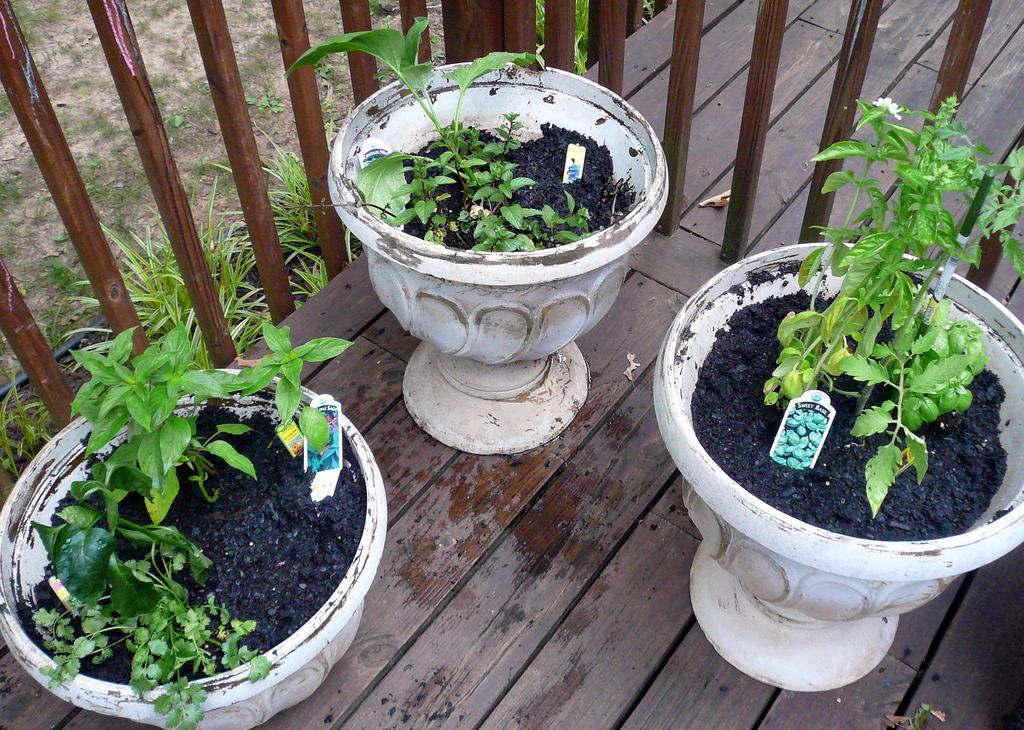Please provide a concise description of this image. In this image there are three pots are having plants in it. Pots are kept on the wooden floor. Pots are surrounded by the fence. Behind the fence at the left side there are few pots having plants are kept on the land having grass on it. 